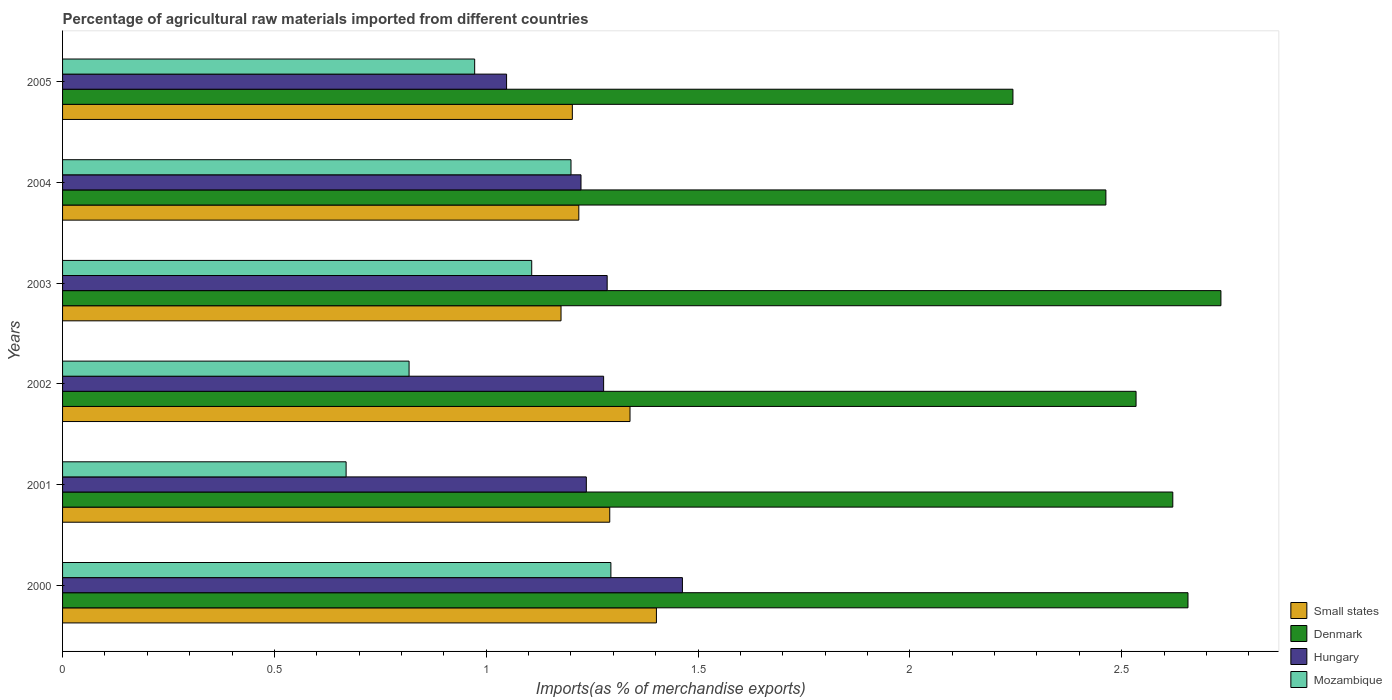How many bars are there on the 5th tick from the top?
Offer a very short reply. 4. How many bars are there on the 1st tick from the bottom?
Make the answer very short. 4. What is the percentage of imports to different countries in Small states in 2004?
Keep it short and to the point. 1.22. Across all years, what is the maximum percentage of imports to different countries in Denmark?
Offer a very short reply. 2.73. Across all years, what is the minimum percentage of imports to different countries in Small states?
Your answer should be compact. 1.18. In which year was the percentage of imports to different countries in Denmark minimum?
Keep it short and to the point. 2005. What is the total percentage of imports to different countries in Denmark in the graph?
Keep it short and to the point. 15.25. What is the difference between the percentage of imports to different countries in Mozambique in 2003 and that in 2005?
Provide a succinct answer. 0.13. What is the difference between the percentage of imports to different countries in Mozambique in 2001 and the percentage of imports to different countries in Denmark in 2003?
Make the answer very short. -2.06. What is the average percentage of imports to different countries in Small states per year?
Make the answer very short. 1.27. In the year 2005, what is the difference between the percentage of imports to different countries in Mozambique and percentage of imports to different countries in Small states?
Your response must be concise. -0.23. In how many years, is the percentage of imports to different countries in Denmark greater than 1.6 %?
Provide a short and direct response. 6. What is the ratio of the percentage of imports to different countries in Mozambique in 2001 to that in 2004?
Give a very brief answer. 0.56. What is the difference between the highest and the second highest percentage of imports to different countries in Mozambique?
Provide a succinct answer. 0.09. What is the difference between the highest and the lowest percentage of imports to different countries in Hungary?
Give a very brief answer. 0.42. Is it the case that in every year, the sum of the percentage of imports to different countries in Hungary and percentage of imports to different countries in Denmark is greater than the sum of percentage of imports to different countries in Mozambique and percentage of imports to different countries in Small states?
Provide a short and direct response. Yes. What does the 3rd bar from the top in 2003 represents?
Your response must be concise. Denmark. What does the 4th bar from the bottom in 2001 represents?
Give a very brief answer. Mozambique. Is it the case that in every year, the sum of the percentage of imports to different countries in Denmark and percentage of imports to different countries in Small states is greater than the percentage of imports to different countries in Mozambique?
Give a very brief answer. Yes. How many bars are there?
Your answer should be compact. 24. Are all the bars in the graph horizontal?
Offer a terse response. Yes. How many years are there in the graph?
Ensure brevity in your answer.  6. Are the values on the major ticks of X-axis written in scientific E-notation?
Keep it short and to the point. No. How many legend labels are there?
Ensure brevity in your answer.  4. How are the legend labels stacked?
Make the answer very short. Vertical. What is the title of the graph?
Make the answer very short. Percentage of agricultural raw materials imported from different countries. What is the label or title of the X-axis?
Make the answer very short. Imports(as % of merchandise exports). What is the label or title of the Y-axis?
Provide a succinct answer. Years. What is the Imports(as % of merchandise exports) in Small states in 2000?
Make the answer very short. 1.4. What is the Imports(as % of merchandise exports) in Denmark in 2000?
Offer a very short reply. 2.66. What is the Imports(as % of merchandise exports) of Hungary in 2000?
Provide a short and direct response. 1.46. What is the Imports(as % of merchandise exports) of Mozambique in 2000?
Keep it short and to the point. 1.29. What is the Imports(as % of merchandise exports) of Small states in 2001?
Ensure brevity in your answer.  1.29. What is the Imports(as % of merchandise exports) of Denmark in 2001?
Provide a succinct answer. 2.62. What is the Imports(as % of merchandise exports) of Hungary in 2001?
Offer a terse response. 1.24. What is the Imports(as % of merchandise exports) in Mozambique in 2001?
Offer a very short reply. 0.67. What is the Imports(as % of merchandise exports) of Small states in 2002?
Provide a short and direct response. 1.34. What is the Imports(as % of merchandise exports) of Denmark in 2002?
Provide a succinct answer. 2.53. What is the Imports(as % of merchandise exports) of Hungary in 2002?
Offer a terse response. 1.28. What is the Imports(as % of merchandise exports) in Mozambique in 2002?
Make the answer very short. 0.82. What is the Imports(as % of merchandise exports) of Small states in 2003?
Offer a terse response. 1.18. What is the Imports(as % of merchandise exports) in Denmark in 2003?
Your answer should be compact. 2.73. What is the Imports(as % of merchandise exports) in Hungary in 2003?
Provide a short and direct response. 1.29. What is the Imports(as % of merchandise exports) of Mozambique in 2003?
Your answer should be very brief. 1.11. What is the Imports(as % of merchandise exports) of Small states in 2004?
Your response must be concise. 1.22. What is the Imports(as % of merchandise exports) of Denmark in 2004?
Your response must be concise. 2.46. What is the Imports(as % of merchandise exports) in Hungary in 2004?
Make the answer very short. 1.22. What is the Imports(as % of merchandise exports) in Mozambique in 2004?
Your answer should be compact. 1.2. What is the Imports(as % of merchandise exports) of Small states in 2005?
Your answer should be very brief. 1.2. What is the Imports(as % of merchandise exports) of Denmark in 2005?
Make the answer very short. 2.24. What is the Imports(as % of merchandise exports) in Hungary in 2005?
Provide a short and direct response. 1.05. What is the Imports(as % of merchandise exports) in Mozambique in 2005?
Your answer should be compact. 0.97. Across all years, what is the maximum Imports(as % of merchandise exports) of Small states?
Your response must be concise. 1.4. Across all years, what is the maximum Imports(as % of merchandise exports) of Denmark?
Ensure brevity in your answer.  2.73. Across all years, what is the maximum Imports(as % of merchandise exports) in Hungary?
Your response must be concise. 1.46. Across all years, what is the maximum Imports(as % of merchandise exports) in Mozambique?
Make the answer very short. 1.29. Across all years, what is the minimum Imports(as % of merchandise exports) of Small states?
Keep it short and to the point. 1.18. Across all years, what is the minimum Imports(as % of merchandise exports) in Denmark?
Your response must be concise. 2.24. Across all years, what is the minimum Imports(as % of merchandise exports) of Hungary?
Give a very brief answer. 1.05. Across all years, what is the minimum Imports(as % of merchandise exports) of Mozambique?
Your answer should be compact. 0.67. What is the total Imports(as % of merchandise exports) in Small states in the graph?
Make the answer very short. 7.63. What is the total Imports(as % of merchandise exports) in Denmark in the graph?
Offer a terse response. 15.25. What is the total Imports(as % of merchandise exports) in Hungary in the graph?
Give a very brief answer. 7.53. What is the total Imports(as % of merchandise exports) of Mozambique in the graph?
Provide a succinct answer. 6.06. What is the difference between the Imports(as % of merchandise exports) in Small states in 2000 and that in 2001?
Offer a terse response. 0.11. What is the difference between the Imports(as % of merchandise exports) in Denmark in 2000 and that in 2001?
Your answer should be very brief. 0.04. What is the difference between the Imports(as % of merchandise exports) of Hungary in 2000 and that in 2001?
Your answer should be compact. 0.23. What is the difference between the Imports(as % of merchandise exports) in Small states in 2000 and that in 2002?
Your answer should be very brief. 0.06. What is the difference between the Imports(as % of merchandise exports) of Denmark in 2000 and that in 2002?
Give a very brief answer. 0.12. What is the difference between the Imports(as % of merchandise exports) of Hungary in 2000 and that in 2002?
Make the answer very short. 0.19. What is the difference between the Imports(as % of merchandise exports) in Mozambique in 2000 and that in 2002?
Provide a succinct answer. 0.48. What is the difference between the Imports(as % of merchandise exports) in Small states in 2000 and that in 2003?
Provide a short and direct response. 0.23. What is the difference between the Imports(as % of merchandise exports) of Denmark in 2000 and that in 2003?
Provide a short and direct response. -0.08. What is the difference between the Imports(as % of merchandise exports) in Hungary in 2000 and that in 2003?
Ensure brevity in your answer.  0.18. What is the difference between the Imports(as % of merchandise exports) of Mozambique in 2000 and that in 2003?
Give a very brief answer. 0.19. What is the difference between the Imports(as % of merchandise exports) of Small states in 2000 and that in 2004?
Offer a terse response. 0.18. What is the difference between the Imports(as % of merchandise exports) in Denmark in 2000 and that in 2004?
Provide a succinct answer. 0.19. What is the difference between the Imports(as % of merchandise exports) of Hungary in 2000 and that in 2004?
Your answer should be very brief. 0.24. What is the difference between the Imports(as % of merchandise exports) in Mozambique in 2000 and that in 2004?
Make the answer very short. 0.09. What is the difference between the Imports(as % of merchandise exports) of Small states in 2000 and that in 2005?
Make the answer very short. 0.2. What is the difference between the Imports(as % of merchandise exports) of Denmark in 2000 and that in 2005?
Give a very brief answer. 0.41. What is the difference between the Imports(as % of merchandise exports) in Hungary in 2000 and that in 2005?
Keep it short and to the point. 0.42. What is the difference between the Imports(as % of merchandise exports) of Mozambique in 2000 and that in 2005?
Make the answer very short. 0.32. What is the difference between the Imports(as % of merchandise exports) of Small states in 2001 and that in 2002?
Give a very brief answer. -0.05. What is the difference between the Imports(as % of merchandise exports) in Denmark in 2001 and that in 2002?
Ensure brevity in your answer.  0.09. What is the difference between the Imports(as % of merchandise exports) of Hungary in 2001 and that in 2002?
Make the answer very short. -0.04. What is the difference between the Imports(as % of merchandise exports) in Mozambique in 2001 and that in 2002?
Ensure brevity in your answer.  -0.15. What is the difference between the Imports(as % of merchandise exports) in Small states in 2001 and that in 2003?
Keep it short and to the point. 0.12. What is the difference between the Imports(as % of merchandise exports) in Denmark in 2001 and that in 2003?
Ensure brevity in your answer.  -0.11. What is the difference between the Imports(as % of merchandise exports) of Hungary in 2001 and that in 2003?
Provide a succinct answer. -0.05. What is the difference between the Imports(as % of merchandise exports) of Mozambique in 2001 and that in 2003?
Provide a short and direct response. -0.44. What is the difference between the Imports(as % of merchandise exports) in Small states in 2001 and that in 2004?
Offer a terse response. 0.07. What is the difference between the Imports(as % of merchandise exports) in Denmark in 2001 and that in 2004?
Your answer should be compact. 0.16. What is the difference between the Imports(as % of merchandise exports) in Hungary in 2001 and that in 2004?
Your answer should be compact. 0.01. What is the difference between the Imports(as % of merchandise exports) in Mozambique in 2001 and that in 2004?
Give a very brief answer. -0.53. What is the difference between the Imports(as % of merchandise exports) of Small states in 2001 and that in 2005?
Provide a succinct answer. 0.09. What is the difference between the Imports(as % of merchandise exports) in Denmark in 2001 and that in 2005?
Give a very brief answer. 0.38. What is the difference between the Imports(as % of merchandise exports) in Hungary in 2001 and that in 2005?
Offer a very short reply. 0.19. What is the difference between the Imports(as % of merchandise exports) in Mozambique in 2001 and that in 2005?
Make the answer very short. -0.3. What is the difference between the Imports(as % of merchandise exports) in Small states in 2002 and that in 2003?
Provide a short and direct response. 0.16. What is the difference between the Imports(as % of merchandise exports) in Denmark in 2002 and that in 2003?
Ensure brevity in your answer.  -0.2. What is the difference between the Imports(as % of merchandise exports) of Hungary in 2002 and that in 2003?
Keep it short and to the point. -0.01. What is the difference between the Imports(as % of merchandise exports) in Mozambique in 2002 and that in 2003?
Make the answer very short. -0.29. What is the difference between the Imports(as % of merchandise exports) in Small states in 2002 and that in 2004?
Provide a short and direct response. 0.12. What is the difference between the Imports(as % of merchandise exports) of Denmark in 2002 and that in 2004?
Give a very brief answer. 0.07. What is the difference between the Imports(as % of merchandise exports) in Hungary in 2002 and that in 2004?
Your answer should be very brief. 0.05. What is the difference between the Imports(as % of merchandise exports) of Mozambique in 2002 and that in 2004?
Make the answer very short. -0.38. What is the difference between the Imports(as % of merchandise exports) in Small states in 2002 and that in 2005?
Your answer should be compact. 0.14. What is the difference between the Imports(as % of merchandise exports) in Denmark in 2002 and that in 2005?
Your answer should be very brief. 0.29. What is the difference between the Imports(as % of merchandise exports) of Hungary in 2002 and that in 2005?
Ensure brevity in your answer.  0.23. What is the difference between the Imports(as % of merchandise exports) of Mozambique in 2002 and that in 2005?
Keep it short and to the point. -0.15. What is the difference between the Imports(as % of merchandise exports) of Small states in 2003 and that in 2004?
Make the answer very short. -0.04. What is the difference between the Imports(as % of merchandise exports) of Denmark in 2003 and that in 2004?
Make the answer very short. 0.27. What is the difference between the Imports(as % of merchandise exports) in Hungary in 2003 and that in 2004?
Provide a short and direct response. 0.06. What is the difference between the Imports(as % of merchandise exports) in Mozambique in 2003 and that in 2004?
Provide a succinct answer. -0.09. What is the difference between the Imports(as % of merchandise exports) of Small states in 2003 and that in 2005?
Give a very brief answer. -0.03. What is the difference between the Imports(as % of merchandise exports) of Denmark in 2003 and that in 2005?
Offer a very short reply. 0.49. What is the difference between the Imports(as % of merchandise exports) of Hungary in 2003 and that in 2005?
Your response must be concise. 0.24. What is the difference between the Imports(as % of merchandise exports) of Mozambique in 2003 and that in 2005?
Offer a terse response. 0.13. What is the difference between the Imports(as % of merchandise exports) of Small states in 2004 and that in 2005?
Provide a short and direct response. 0.02. What is the difference between the Imports(as % of merchandise exports) in Denmark in 2004 and that in 2005?
Keep it short and to the point. 0.22. What is the difference between the Imports(as % of merchandise exports) of Hungary in 2004 and that in 2005?
Ensure brevity in your answer.  0.18. What is the difference between the Imports(as % of merchandise exports) of Mozambique in 2004 and that in 2005?
Offer a very short reply. 0.23. What is the difference between the Imports(as % of merchandise exports) of Small states in 2000 and the Imports(as % of merchandise exports) of Denmark in 2001?
Keep it short and to the point. -1.22. What is the difference between the Imports(as % of merchandise exports) of Small states in 2000 and the Imports(as % of merchandise exports) of Hungary in 2001?
Provide a short and direct response. 0.17. What is the difference between the Imports(as % of merchandise exports) in Small states in 2000 and the Imports(as % of merchandise exports) in Mozambique in 2001?
Offer a terse response. 0.73. What is the difference between the Imports(as % of merchandise exports) in Denmark in 2000 and the Imports(as % of merchandise exports) in Hungary in 2001?
Give a very brief answer. 1.42. What is the difference between the Imports(as % of merchandise exports) in Denmark in 2000 and the Imports(as % of merchandise exports) in Mozambique in 2001?
Ensure brevity in your answer.  1.99. What is the difference between the Imports(as % of merchandise exports) in Hungary in 2000 and the Imports(as % of merchandise exports) in Mozambique in 2001?
Give a very brief answer. 0.79. What is the difference between the Imports(as % of merchandise exports) of Small states in 2000 and the Imports(as % of merchandise exports) of Denmark in 2002?
Make the answer very short. -1.13. What is the difference between the Imports(as % of merchandise exports) in Small states in 2000 and the Imports(as % of merchandise exports) in Hungary in 2002?
Make the answer very short. 0.12. What is the difference between the Imports(as % of merchandise exports) in Small states in 2000 and the Imports(as % of merchandise exports) in Mozambique in 2002?
Make the answer very short. 0.58. What is the difference between the Imports(as % of merchandise exports) of Denmark in 2000 and the Imports(as % of merchandise exports) of Hungary in 2002?
Your answer should be very brief. 1.38. What is the difference between the Imports(as % of merchandise exports) in Denmark in 2000 and the Imports(as % of merchandise exports) in Mozambique in 2002?
Provide a succinct answer. 1.84. What is the difference between the Imports(as % of merchandise exports) of Hungary in 2000 and the Imports(as % of merchandise exports) of Mozambique in 2002?
Make the answer very short. 0.65. What is the difference between the Imports(as % of merchandise exports) of Small states in 2000 and the Imports(as % of merchandise exports) of Denmark in 2003?
Keep it short and to the point. -1.33. What is the difference between the Imports(as % of merchandise exports) of Small states in 2000 and the Imports(as % of merchandise exports) of Hungary in 2003?
Make the answer very short. 0.12. What is the difference between the Imports(as % of merchandise exports) in Small states in 2000 and the Imports(as % of merchandise exports) in Mozambique in 2003?
Keep it short and to the point. 0.29. What is the difference between the Imports(as % of merchandise exports) of Denmark in 2000 and the Imports(as % of merchandise exports) of Hungary in 2003?
Ensure brevity in your answer.  1.37. What is the difference between the Imports(as % of merchandise exports) in Denmark in 2000 and the Imports(as % of merchandise exports) in Mozambique in 2003?
Your answer should be compact. 1.55. What is the difference between the Imports(as % of merchandise exports) of Hungary in 2000 and the Imports(as % of merchandise exports) of Mozambique in 2003?
Provide a succinct answer. 0.36. What is the difference between the Imports(as % of merchandise exports) in Small states in 2000 and the Imports(as % of merchandise exports) in Denmark in 2004?
Offer a terse response. -1.06. What is the difference between the Imports(as % of merchandise exports) in Small states in 2000 and the Imports(as % of merchandise exports) in Hungary in 2004?
Your response must be concise. 0.18. What is the difference between the Imports(as % of merchandise exports) in Small states in 2000 and the Imports(as % of merchandise exports) in Mozambique in 2004?
Offer a very short reply. 0.2. What is the difference between the Imports(as % of merchandise exports) of Denmark in 2000 and the Imports(as % of merchandise exports) of Hungary in 2004?
Your response must be concise. 1.43. What is the difference between the Imports(as % of merchandise exports) of Denmark in 2000 and the Imports(as % of merchandise exports) of Mozambique in 2004?
Your answer should be very brief. 1.46. What is the difference between the Imports(as % of merchandise exports) of Hungary in 2000 and the Imports(as % of merchandise exports) of Mozambique in 2004?
Offer a terse response. 0.26. What is the difference between the Imports(as % of merchandise exports) of Small states in 2000 and the Imports(as % of merchandise exports) of Denmark in 2005?
Provide a succinct answer. -0.84. What is the difference between the Imports(as % of merchandise exports) in Small states in 2000 and the Imports(as % of merchandise exports) in Hungary in 2005?
Your answer should be very brief. 0.35. What is the difference between the Imports(as % of merchandise exports) of Small states in 2000 and the Imports(as % of merchandise exports) of Mozambique in 2005?
Keep it short and to the point. 0.43. What is the difference between the Imports(as % of merchandise exports) of Denmark in 2000 and the Imports(as % of merchandise exports) of Hungary in 2005?
Your answer should be compact. 1.61. What is the difference between the Imports(as % of merchandise exports) in Denmark in 2000 and the Imports(as % of merchandise exports) in Mozambique in 2005?
Provide a short and direct response. 1.68. What is the difference between the Imports(as % of merchandise exports) of Hungary in 2000 and the Imports(as % of merchandise exports) of Mozambique in 2005?
Provide a succinct answer. 0.49. What is the difference between the Imports(as % of merchandise exports) in Small states in 2001 and the Imports(as % of merchandise exports) in Denmark in 2002?
Ensure brevity in your answer.  -1.24. What is the difference between the Imports(as % of merchandise exports) in Small states in 2001 and the Imports(as % of merchandise exports) in Hungary in 2002?
Make the answer very short. 0.01. What is the difference between the Imports(as % of merchandise exports) in Small states in 2001 and the Imports(as % of merchandise exports) in Mozambique in 2002?
Provide a succinct answer. 0.47. What is the difference between the Imports(as % of merchandise exports) in Denmark in 2001 and the Imports(as % of merchandise exports) in Hungary in 2002?
Provide a short and direct response. 1.34. What is the difference between the Imports(as % of merchandise exports) of Denmark in 2001 and the Imports(as % of merchandise exports) of Mozambique in 2002?
Offer a very short reply. 1.8. What is the difference between the Imports(as % of merchandise exports) of Hungary in 2001 and the Imports(as % of merchandise exports) of Mozambique in 2002?
Make the answer very short. 0.42. What is the difference between the Imports(as % of merchandise exports) in Small states in 2001 and the Imports(as % of merchandise exports) in Denmark in 2003?
Provide a short and direct response. -1.44. What is the difference between the Imports(as % of merchandise exports) of Small states in 2001 and the Imports(as % of merchandise exports) of Hungary in 2003?
Offer a very short reply. 0.01. What is the difference between the Imports(as % of merchandise exports) in Small states in 2001 and the Imports(as % of merchandise exports) in Mozambique in 2003?
Your answer should be very brief. 0.18. What is the difference between the Imports(as % of merchandise exports) of Denmark in 2001 and the Imports(as % of merchandise exports) of Hungary in 2003?
Offer a very short reply. 1.34. What is the difference between the Imports(as % of merchandise exports) in Denmark in 2001 and the Imports(as % of merchandise exports) in Mozambique in 2003?
Your answer should be very brief. 1.51. What is the difference between the Imports(as % of merchandise exports) in Hungary in 2001 and the Imports(as % of merchandise exports) in Mozambique in 2003?
Your answer should be compact. 0.13. What is the difference between the Imports(as % of merchandise exports) in Small states in 2001 and the Imports(as % of merchandise exports) in Denmark in 2004?
Make the answer very short. -1.17. What is the difference between the Imports(as % of merchandise exports) of Small states in 2001 and the Imports(as % of merchandise exports) of Hungary in 2004?
Your response must be concise. 0.07. What is the difference between the Imports(as % of merchandise exports) in Small states in 2001 and the Imports(as % of merchandise exports) in Mozambique in 2004?
Keep it short and to the point. 0.09. What is the difference between the Imports(as % of merchandise exports) in Denmark in 2001 and the Imports(as % of merchandise exports) in Hungary in 2004?
Provide a short and direct response. 1.4. What is the difference between the Imports(as % of merchandise exports) of Denmark in 2001 and the Imports(as % of merchandise exports) of Mozambique in 2004?
Ensure brevity in your answer.  1.42. What is the difference between the Imports(as % of merchandise exports) in Hungary in 2001 and the Imports(as % of merchandise exports) in Mozambique in 2004?
Provide a short and direct response. 0.04. What is the difference between the Imports(as % of merchandise exports) in Small states in 2001 and the Imports(as % of merchandise exports) in Denmark in 2005?
Offer a very short reply. -0.95. What is the difference between the Imports(as % of merchandise exports) of Small states in 2001 and the Imports(as % of merchandise exports) of Hungary in 2005?
Your answer should be compact. 0.24. What is the difference between the Imports(as % of merchandise exports) of Small states in 2001 and the Imports(as % of merchandise exports) of Mozambique in 2005?
Give a very brief answer. 0.32. What is the difference between the Imports(as % of merchandise exports) in Denmark in 2001 and the Imports(as % of merchandise exports) in Hungary in 2005?
Give a very brief answer. 1.57. What is the difference between the Imports(as % of merchandise exports) in Denmark in 2001 and the Imports(as % of merchandise exports) in Mozambique in 2005?
Offer a very short reply. 1.65. What is the difference between the Imports(as % of merchandise exports) in Hungary in 2001 and the Imports(as % of merchandise exports) in Mozambique in 2005?
Your response must be concise. 0.26. What is the difference between the Imports(as % of merchandise exports) of Small states in 2002 and the Imports(as % of merchandise exports) of Denmark in 2003?
Offer a very short reply. -1.39. What is the difference between the Imports(as % of merchandise exports) of Small states in 2002 and the Imports(as % of merchandise exports) of Hungary in 2003?
Your answer should be compact. 0.05. What is the difference between the Imports(as % of merchandise exports) in Small states in 2002 and the Imports(as % of merchandise exports) in Mozambique in 2003?
Your answer should be very brief. 0.23. What is the difference between the Imports(as % of merchandise exports) of Denmark in 2002 and the Imports(as % of merchandise exports) of Hungary in 2003?
Your answer should be very brief. 1.25. What is the difference between the Imports(as % of merchandise exports) of Denmark in 2002 and the Imports(as % of merchandise exports) of Mozambique in 2003?
Offer a terse response. 1.43. What is the difference between the Imports(as % of merchandise exports) of Hungary in 2002 and the Imports(as % of merchandise exports) of Mozambique in 2003?
Ensure brevity in your answer.  0.17. What is the difference between the Imports(as % of merchandise exports) of Small states in 2002 and the Imports(as % of merchandise exports) of Denmark in 2004?
Offer a very short reply. -1.12. What is the difference between the Imports(as % of merchandise exports) in Small states in 2002 and the Imports(as % of merchandise exports) in Hungary in 2004?
Give a very brief answer. 0.12. What is the difference between the Imports(as % of merchandise exports) of Small states in 2002 and the Imports(as % of merchandise exports) of Mozambique in 2004?
Ensure brevity in your answer.  0.14. What is the difference between the Imports(as % of merchandise exports) in Denmark in 2002 and the Imports(as % of merchandise exports) in Hungary in 2004?
Ensure brevity in your answer.  1.31. What is the difference between the Imports(as % of merchandise exports) in Denmark in 2002 and the Imports(as % of merchandise exports) in Mozambique in 2004?
Offer a very short reply. 1.33. What is the difference between the Imports(as % of merchandise exports) in Hungary in 2002 and the Imports(as % of merchandise exports) in Mozambique in 2004?
Ensure brevity in your answer.  0.08. What is the difference between the Imports(as % of merchandise exports) in Small states in 2002 and the Imports(as % of merchandise exports) in Denmark in 2005?
Provide a succinct answer. -0.9. What is the difference between the Imports(as % of merchandise exports) in Small states in 2002 and the Imports(as % of merchandise exports) in Hungary in 2005?
Your answer should be compact. 0.29. What is the difference between the Imports(as % of merchandise exports) in Small states in 2002 and the Imports(as % of merchandise exports) in Mozambique in 2005?
Provide a short and direct response. 0.37. What is the difference between the Imports(as % of merchandise exports) of Denmark in 2002 and the Imports(as % of merchandise exports) of Hungary in 2005?
Offer a terse response. 1.49. What is the difference between the Imports(as % of merchandise exports) in Denmark in 2002 and the Imports(as % of merchandise exports) in Mozambique in 2005?
Ensure brevity in your answer.  1.56. What is the difference between the Imports(as % of merchandise exports) in Hungary in 2002 and the Imports(as % of merchandise exports) in Mozambique in 2005?
Keep it short and to the point. 0.3. What is the difference between the Imports(as % of merchandise exports) in Small states in 2003 and the Imports(as % of merchandise exports) in Denmark in 2004?
Provide a succinct answer. -1.29. What is the difference between the Imports(as % of merchandise exports) of Small states in 2003 and the Imports(as % of merchandise exports) of Hungary in 2004?
Offer a terse response. -0.05. What is the difference between the Imports(as % of merchandise exports) in Small states in 2003 and the Imports(as % of merchandise exports) in Mozambique in 2004?
Provide a short and direct response. -0.02. What is the difference between the Imports(as % of merchandise exports) in Denmark in 2003 and the Imports(as % of merchandise exports) in Hungary in 2004?
Provide a succinct answer. 1.51. What is the difference between the Imports(as % of merchandise exports) of Denmark in 2003 and the Imports(as % of merchandise exports) of Mozambique in 2004?
Provide a short and direct response. 1.53. What is the difference between the Imports(as % of merchandise exports) of Hungary in 2003 and the Imports(as % of merchandise exports) of Mozambique in 2004?
Your answer should be very brief. 0.09. What is the difference between the Imports(as % of merchandise exports) in Small states in 2003 and the Imports(as % of merchandise exports) in Denmark in 2005?
Make the answer very short. -1.07. What is the difference between the Imports(as % of merchandise exports) of Small states in 2003 and the Imports(as % of merchandise exports) of Hungary in 2005?
Your answer should be compact. 0.13. What is the difference between the Imports(as % of merchandise exports) in Small states in 2003 and the Imports(as % of merchandise exports) in Mozambique in 2005?
Your answer should be very brief. 0.2. What is the difference between the Imports(as % of merchandise exports) in Denmark in 2003 and the Imports(as % of merchandise exports) in Hungary in 2005?
Offer a very short reply. 1.69. What is the difference between the Imports(as % of merchandise exports) in Denmark in 2003 and the Imports(as % of merchandise exports) in Mozambique in 2005?
Offer a terse response. 1.76. What is the difference between the Imports(as % of merchandise exports) in Hungary in 2003 and the Imports(as % of merchandise exports) in Mozambique in 2005?
Keep it short and to the point. 0.31. What is the difference between the Imports(as % of merchandise exports) of Small states in 2004 and the Imports(as % of merchandise exports) of Denmark in 2005?
Keep it short and to the point. -1.02. What is the difference between the Imports(as % of merchandise exports) of Small states in 2004 and the Imports(as % of merchandise exports) of Hungary in 2005?
Offer a very short reply. 0.17. What is the difference between the Imports(as % of merchandise exports) in Small states in 2004 and the Imports(as % of merchandise exports) in Mozambique in 2005?
Your answer should be very brief. 0.25. What is the difference between the Imports(as % of merchandise exports) of Denmark in 2004 and the Imports(as % of merchandise exports) of Hungary in 2005?
Your answer should be compact. 1.41. What is the difference between the Imports(as % of merchandise exports) in Denmark in 2004 and the Imports(as % of merchandise exports) in Mozambique in 2005?
Provide a succinct answer. 1.49. What is the difference between the Imports(as % of merchandise exports) of Hungary in 2004 and the Imports(as % of merchandise exports) of Mozambique in 2005?
Offer a terse response. 0.25. What is the average Imports(as % of merchandise exports) of Small states per year?
Provide a short and direct response. 1.27. What is the average Imports(as % of merchandise exports) in Denmark per year?
Ensure brevity in your answer.  2.54. What is the average Imports(as % of merchandise exports) in Hungary per year?
Ensure brevity in your answer.  1.26. What is the average Imports(as % of merchandise exports) in Mozambique per year?
Offer a terse response. 1.01. In the year 2000, what is the difference between the Imports(as % of merchandise exports) in Small states and Imports(as % of merchandise exports) in Denmark?
Ensure brevity in your answer.  -1.25. In the year 2000, what is the difference between the Imports(as % of merchandise exports) of Small states and Imports(as % of merchandise exports) of Hungary?
Provide a short and direct response. -0.06. In the year 2000, what is the difference between the Imports(as % of merchandise exports) of Small states and Imports(as % of merchandise exports) of Mozambique?
Offer a terse response. 0.11. In the year 2000, what is the difference between the Imports(as % of merchandise exports) in Denmark and Imports(as % of merchandise exports) in Hungary?
Keep it short and to the point. 1.19. In the year 2000, what is the difference between the Imports(as % of merchandise exports) of Denmark and Imports(as % of merchandise exports) of Mozambique?
Ensure brevity in your answer.  1.36. In the year 2000, what is the difference between the Imports(as % of merchandise exports) of Hungary and Imports(as % of merchandise exports) of Mozambique?
Offer a terse response. 0.17. In the year 2001, what is the difference between the Imports(as % of merchandise exports) of Small states and Imports(as % of merchandise exports) of Denmark?
Provide a short and direct response. -1.33. In the year 2001, what is the difference between the Imports(as % of merchandise exports) in Small states and Imports(as % of merchandise exports) in Hungary?
Offer a terse response. 0.06. In the year 2001, what is the difference between the Imports(as % of merchandise exports) in Small states and Imports(as % of merchandise exports) in Mozambique?
Ensure brevity in your answer.  0.62. In the year 2001, what is the difference between the Imports(as % of merchandise exports) in Denmark and Imports(as % of merchandise exports) in Hungary?
Ensure brevity in your answer.  1.38. In the year 2001, what is the difference between the Imports(as % of merchandise exports) in Denmark and Imports(as % of merchandise exports) in Mozambique?
Provide a succinct answer. 1.95. In the year 2001, what is the difference between the Imports(as % of merchandise exports) in Hungary and Imports(as % of merchandise exports) in Mozambique?
Ensure brevity in your answer.  0.57. In the year 2002, what is the difference between the Imports(as % of merchandise exports) in Small states and Imports(as % of merchandise exports) in Denmark?
Make the answer very short. -1.19. In the year 2002, what is the difference between the Imports(as % of merchandise exports) in Small states and Imports(as % of merchandise exports) in Hungary?
Your response must be concise. 0.06. In the year 2002, what is the difference between the Imports(as % of merchandise exports) in Small states and Imports(as % of merchandise exports) in Mozambique?
Ensure brevity in your answer.  0.52. In the year 2002, what is the difference between the Imports(as % of merchandise exports) of Denmark and Imports(as % of merchandise exports) of Hungary?
Ensure brevity in your answer.  1.26. In the year 2002, what is the difference between the Imports(as % of merchandise exports) in Denmark and Imports(as % of merchandise exports) in Mozambique?
Provide a succinct answer. 1.72. In the year 2002, what is the difference between the Imports(as % of merchandise exports) in Hungary and Imports(as % of merchandise exports) in Mozambique?
Provide a succinct answer. 0.46. In the year 2003, what is the difference between the Imports(as % of merchandise exports) of Small states and Imports(as % of merchandise exports) of Denmark?
Your answer should be very brief. -1.56. In the year 2003, what is the difference between the Imports(as % of merchandise exports) of Small states and Imports(as % of merchandise exports) of Hungary?
Your answer should be very brief. -0.11. In the year 2003, what is the difference between the Imports(as % of merchandise exports) of Small states and Imports(as % of merchandise exports) of Mozambique?
Keep it short and to the point. 0.07. In the year 2003, what is the difference between the Imports(as % of merchandise exports) in Denmark and Imports(as % of merchandise exports) in Hungary?
Give a very brief answer. 1.45. In the year 2003, what is the difference between the Imports(as % of merchandise exports) of Denmark and Imports(as % of merchandise exports) of Mozambique?
Offer a terse response. 1.63. In the year 2003, what is the difference between the Imports(as % of merchandise exports) in Hungary and Imports(as % of merchandise exports) in Mozambique?
Offer a very short reply. 0.18. In the year 2004, what is the difference between the Imports(as % of merchandise exports) in Small states and Imports(as % of merchandise exports) in Denmark?
Give a very brief answer. -1.24. In the year 2004, what is the difference between the Imports(as % of merchandise exports) of Small states and Imports(as % of merchandise exports) of Hungary?
Ensure brevity in your answer.  -0.01. In the year 2004, what is the difference between the Imports(as % of merchandise exports) of Small states and Imports(as % of merchandise exports) of Mozambique?
Provide a succinct answer. 0.02. In the year 2004, what is the difference between the Imports(as % of merchandise exports) of Denmark and Imports(as % of merchandise exports) of Hungary?
Offer a very short reply. 1.24. In the year 2004, what is the difference between the Imports(as % of merchandise exports) in Denmark and Imports(as % of merchandise exports) in Mozambique?
Your response must be concise. 1.26. In the year 2004, what is the difference between the Imports(as % of merchandise exports) in Hungary and Imports(as % of merchandise exports) in Mozambique?
Your answer should be compact. 0.02. In the year 2005, what is the difference between the Imports(as % of merchandise exports) in Small states and Imports(as % of merchandise exports) in Denmark?
Your answer should be very brief. -1.04. In the year 2005, what is the difference between the Imports(as % of merchandise exports) of Small states and Imports(as % of merchandise exports) of Hungary?
Your answer should be very brief. 0.16. In the year 2005, what is the difference between the Imports(as % of merchandise exports) of Small states and Imports(as % of merchandise exports) of Mozambique?
Make the answer very short. 0.23. In the year 2005, what is the difference between the Imports(as % of merchandise exports) in Denmark and Imports(as % of merchandise exports) in Hungary?
Make the answer very short. 1.2. In the year 2005, what is the difference between the Imports(as % of merchandise exports) in Denmark and Imports(as % of merchandise exports) in Mozambique?
Your answer should be compact. 1.27. In the year 2005, what is the difference between the Imports(as % of merchandise exports) of Hungary and Imports(as % of merchandise exports) of Mozambique?
Offer a very short reply. 0.08. What is the ratio of the Imports(as % of merchandise exports) of Small states in 2000 to that in 2001?
Your response must be concise. 1.09. What is the ratio of the Imports(as % of merchandise exports) of Denmark in 2000 to that in 2001?
Offer a very short reply. 1.01. What is the ratio of the Imports(as % of merchandise exports) of Hungary in 2000 to that in 2001?
Make the answer very short. 1.18. What is the ratio of the Imports(as % of merchandise exports) in Mozambique in 2000 to that in 2001?
Your answer should be very brief. 1.93. What is the ratio of the Imports(as % of merchandise exports) of Small states in 2000 to that in 2002?
Ensure brevity in your answer.  1.05. What is the ratio of the Imports(as % of merchandise exports) of Denmark in 2000 to that in 2002?
Give a very brief answer. 1.05. What is the ratio of the Imports(as % of merchandise exports) in Hungary in 2000 to that in 2002?
Make the answer very short. 1.15. What is the ratio of the Imports(as % of merchandise exports) in Mozambique in 2000 to that in 2002?
Your response must be concise. 1.58. What is the ratio of the Imports(as % of merchandise exports) of Small states in 2000 to that in 2003?
Offer a very short reply. 1.19. What is the ratio of the Imports(as % of merchandise exports) in Denmark in 2000 to that in 2003?
Make the answer very short. 0.97. What is the ratio of the Imports(as % of merchandise exports) of Hungary in 2000 to that in 2003?
Your answer should be compact. 1.14. What is the ratio of the Imports(as % of merchandise exports) of Mozambique in 2000 to that in 2003?
Ensure brevity in your answer.  1.17. What is the ratio of the Imports(as % of merchandise exports) in Small states in 2000 to that in 2004?
Your answer should be compact. 1.15. What is the ratio of the Imports(as % of merchandise exports) in Denmark in 2000 to that in 2004?
Give a very brief answer. 1.08. What is the ratio of the Imports(as % of merchandise exports) of Hungary in 2000 to that in 2004?
Provide a short and direct response. 1.2. What is the ratio of the Imports(as % of merchandise exports) of Mozambique in 2000 to that in 2004?
Make the answer very short. 1.08. What is the ratio of the Imports(as % of merchandise exports) in Small states in 2000 to that in 2005?
Make the answer very short. 1.16. What is the ratio of the Imports(as % of merchandise exports) in Denmark in 2000 to that in 2005?
Offer a terse response. 1.18. What is the ratio of the Imports(as % of merchandise exports) of Hungary in 2000 to that in 2005?
Offer a terse response. 1.4. What is the ratio of the Imports(as % of merchandise exports) in Mozambique in 2000 to that in 2005?
Provide a short and direct response. 1.33. What is the ratio of the Imports(as % of merchandise exports) in Denmark in 2001 to that in 2002?
Your answer should be compact. 1.03. What is the ratio of the Imports(as % of merchandise exports) of Mozambique in 2001 to that in 2002?
Your answer should be very brief. 0.82. What is the ratio of the Imports(as % of merchandise exports) in Small states in 2001 to that in 2003?
Offer a terse response. 1.1. What is the ratio of the Imports(as % of merchandise exports) in Denmark in 2001 to that in 2003?
Your answer should be very brief. 0.96. What is the ratio of the Imports(as % of merchandise exports) in Hungary in 2001 to that in 2003?
Your answer should be very brief. 0.96. What is the ratio of the Imports(as % of merchandise exports) of Mozambique in 2001 to that in 2003?
Your answer should be very brief. 0.6. What is the ratio of the Imports(as % of merchandise exports) of Small states in 2001 to that in 2004?
Provide a short and direct response. 1.06. What is the ratio of the Imports(as % of merchandise exports) of Denmark in 2001 to that in 2004?
Provide a succinct answer. 1.06. What is the ratio of the Imports(as % of merchandise exports) of Hungary in 2001 to that in 2004?
Offer a terse response. 1.01. What is the ratio of the Imports(as % of merchandise exports) in Mozambique in 2001 to that in 2004?
Make the answer very short. 0.56. What is the ratio of the Imports(as % of merchandise exports) in Small states in 2001 to that in 2005?
Offer a terse response. 1.07. What is the ratio of the Imports(as % of merchandise exports) of Denmark in 2001 to that in 2005?
Give a very brief answer. 1.17. What is the ratio of the Imports(as % of merchandise exports) in Hungary in 2001 to that in 2005?
Offer a very short reply. 1.18. What is the ratio of the Imports(as % of merchandise exports) in Mozambique in 2001 to that in 2005?
Ensure brevity in your answer.  0.69. What is the ratio of the Imports(as % of merchandise exports) in Small states in 2002 to that in 2003?
Provide a short and direct response. 1.14. What is the ratio of the Imports(as % of merchandise exports) of Denmark in 2002 to that in 2003?
Offer a very short reply. 0.93. What is the ratio of the Imports(as % of merchandise exports) of Mozambique in 2002 to that in 2003?
Keep it short and to the point. 0.74. What is the ratio of the Imports(as % of merchandise exports) of Small states in 2002 to that in 2004?
Ensure brevity in your answer.  1.1. What is the ratio of the Imports(as % of merchandise exports) in Denmark in 2002 to that in 2004?
Provide a succinct answer. 1.03. What is the ratio of the Imports(as % of merchandise exports) in Hungary in 2002 to that in 2004?
Keep it short and to the point. 1.04. What is the ratio of the Imports(as % of merchandise exports) in Mozambique in 2002 to that in 2004?
Give a very brief answer. 0.68. What is the ratio of the Imports(as % of merchandise exports) in Small states in 2002 to that in 2005?
Give a very brief answer. 1.11. What is the ratio of the Imports(as % of merchandise exports) in Denmark in 2002 to that in 2005?
Offer a terse response. 1.13. What is the ratio of the Imports(as % of merchandise exports) in Hungary in 2002 to that in 2005?
Keep it short and to the point. 1.22. What is the ratio of the Imports(as % of merchandise exports) in Mozambique in 2002 to that in 2005?
Your answer should be very brief. 0.84. What is the ratio of the Imports(as % of merchandise exports) of Small states in 2003 to that in 2004?
Make the answer very short. 0.97. What is the ratio of the Imports(as % of merchandise exports) of Denmark in 2003 to that in 2004?
Keep it short and to the point. 1.11. What is the ratio of the Imports(as % of merchandise exports) in Hungary in 2003 to that in 2004?
Your answer should be very brief. 1.05. What is the ratio of the Imports(as % of merchandise exports) in Mozambique in 2003 to that in 2004?
Provide a succinct answer. 0.92. What is the ratio of the Imports(as % of merchandise exports) of Small states in 2003 to that in 2005?
Your response must be concise. 0.98. What is the ratio of the Imports(as % of merchandise exports) of Denmark in 2003 to that in 2005?
Your answer should be very brief. 1.22. What is the ratio of the Imports(as % of merchandise exports) of Hungary in 2003 to that in 2005?
Provide a succinct answer. 1.23. What is the ratio of the Imports(as % of merchandise exports) in Mozambique in 2003 to that in 2005?
Provide a succinct answer. 1.14. What is the ratio of the Imports(as % of merchandise exports) in Small states in 2004 to that in 2005?
Keep it short and to the point. 1.01. What is the ratio of the Imports(as % of merchandise exports) of Denmark in 2004 to that in 2005?
Your answer should be compact. 1.1. What is the ratio of the Imports(as % of merchandise exports) of Hungary in 2004 to that in 2005?
Your response must be concise. 1.17. What is the ratio of the Imports(as % of merchandise exports) in Mozambique in 2004 to that in 2005?
Your answer should be compact. 1.23. What is the difference between the highest and the second highest Imports(as % of merchandise exports) in Small states?
Offer a very short reply. 0.06. What is the difference between the highest and the second highest Imports(as % of merchandise exports) in Denmark?
Provide a short and direct response. 0.08. What is the difference between the highest and the second highest Imports(as % of merchandise exports) of Hungary?
Offer a very short reply. 0.18. What is the difference between the highest and the second highest Imports(as % of merchandise exports) of Mozambique?
Your answer should be compact. 0.09. What is the difference between the highest and the lowest Imports(as % of merchandise exports) in Small states?
Your response must be concise. 0.23. What is the difference between the highest and the lowest Imports(as % of merchandise exports) of Denmark?
Offer a very short reply. 0.49. What is the difference between the highest and the lowest Imports(as % of merchandise exports) in Hungary?
Ensure brevity in your answer.  0.42. 